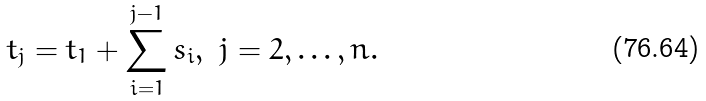<formula> <loc_0><loc_0><loc_500><loc_500>t _ { j } = t _ { 1 } + \sum _ { i = 1 } ^ { j - 1 } s _ { i } , \ j = 2 , \dots , n .</formula> 